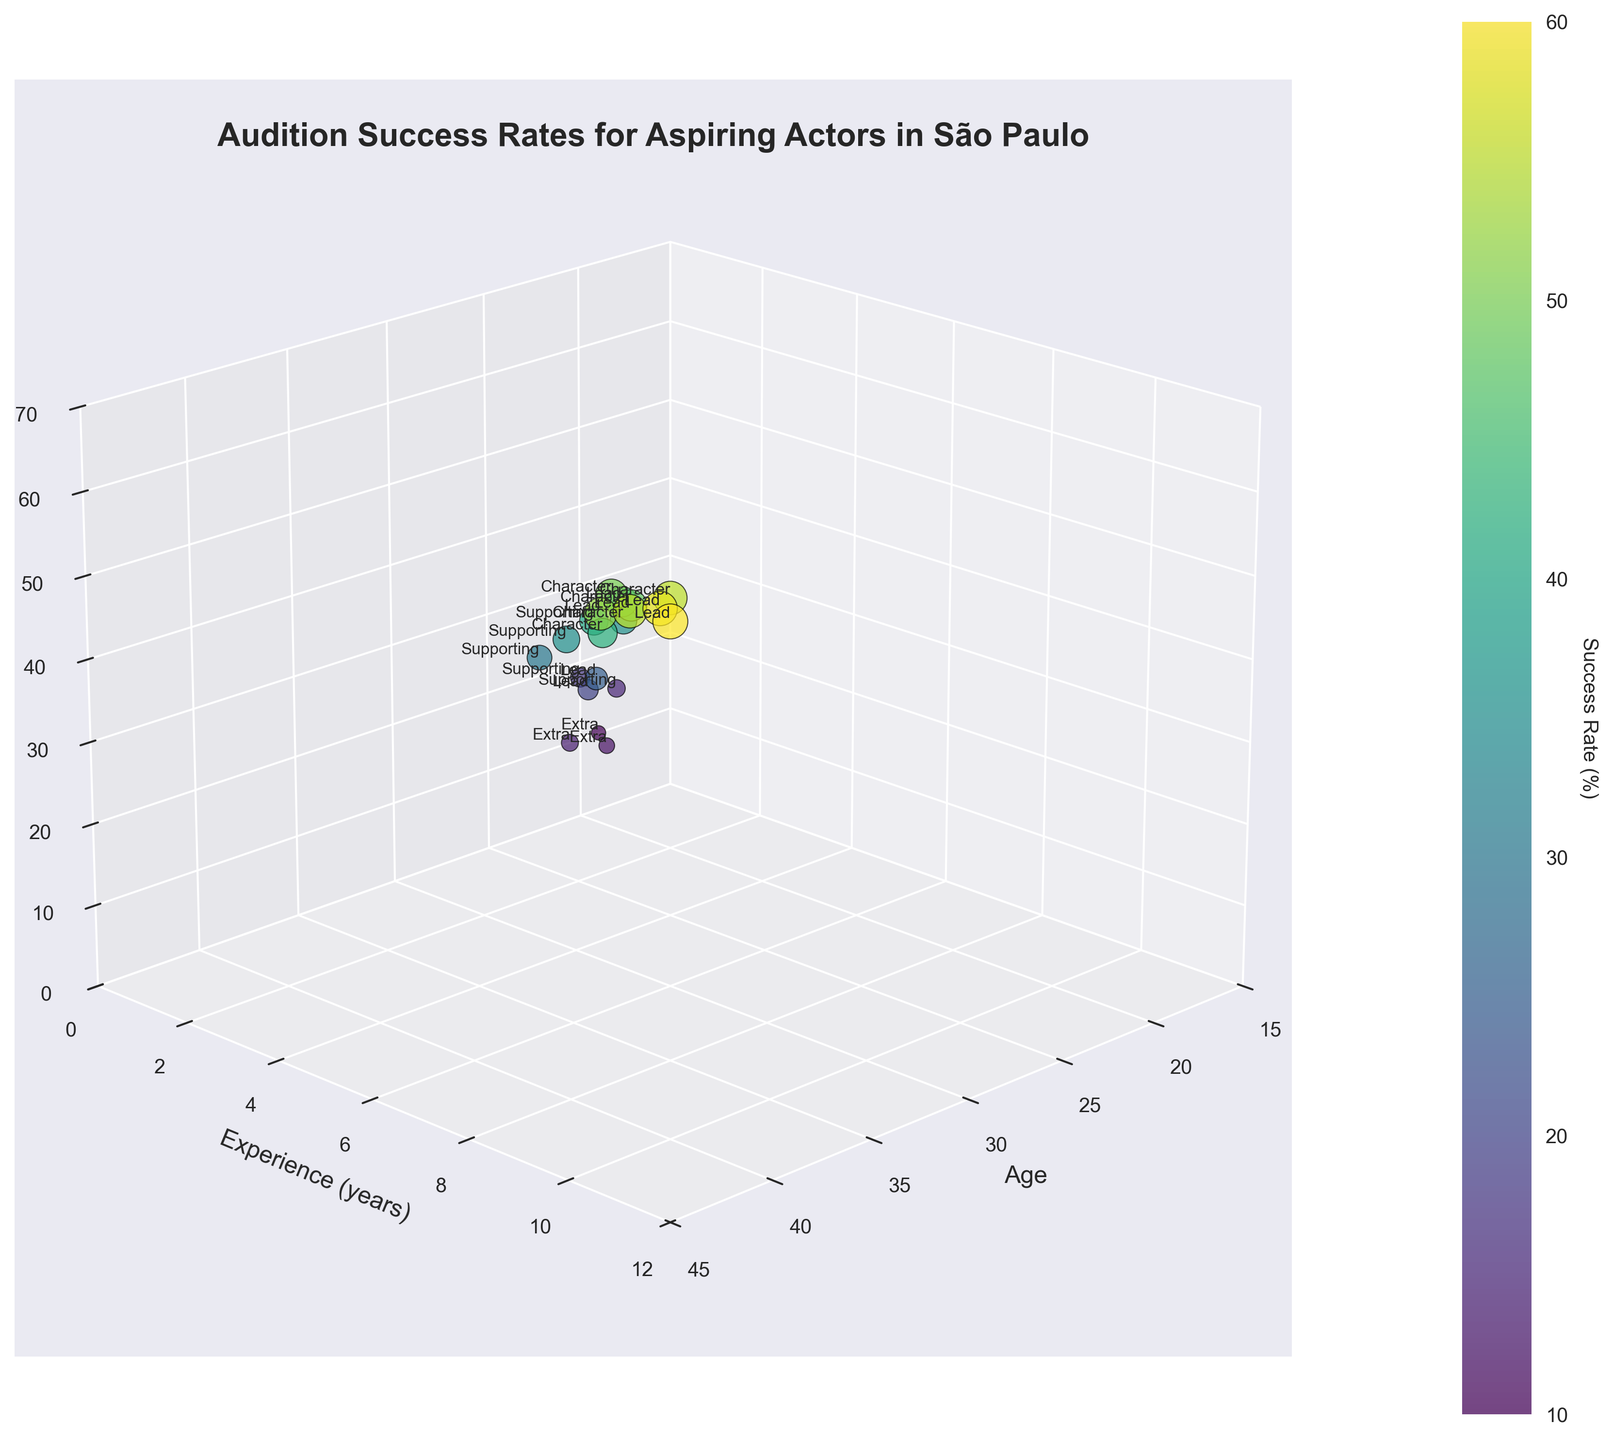What is the title of the 3D scatter plot? The title is prominently displayed at the top of the plot, which reads, "Audition Success Rates for Aspiring Actors in São Paulo".
Answer: Audition Success Rates for Aspiring Actors in São Paulo What are the labels of the X, Y, and Z axes? The labels are found next to each axis. The X-axis is labeled "Age", the Y-axis is labeled "Experience (years)", and the Z-axis is labeled "Success Rate (%)".
Answer: Age, Experience (years), Success Rate (%) Which role type has the highest success rate and what is that rate? Observe the text labels next to the points to identify the role types. The highest success rate is 60%, associated with the role type "Lead".
Answer: Lead, 60% What is the average success rate for actors with five or more years of experience? Look for data points where the experience is 5 years or more, and then calculate the average. These points have the success rates 45, 55, 50, 58, 55, and 52. The sum of these rates is (45 + 55 + 50 + 58 + 55 + 52) = 315, and there are 6 such data points. The average is 315/6 = 52.5
Answer: 52.5 How many data points are labeled with "Character"? Identify the points labeled "Character" and count them. There are 5 such points in the dataset.
Answer: 5 What is the age and experience of the actor with the highest success rate for the "Lead" role? Look at the data points labeled "Lead" and find the one with the highest success rate, which is 60%. The corresponding age and experience are 40 and 10 years respectively.
Answer: Age 40, Experience 10 years Is there a noticeable trend between age and success rate for actors in the "Supporting" role? Observe the data points labeled "Supporting". As age increases (18, 19, 20, 27, 29, 28), the success rates also seem to increase (15, 18, 30, 40, 35). The trend suggests a positive correlation between age and success rate.
Answer: Yes Which role type appears to have the most data points, and how many? Look at the plot and count the number of points for each role type. The role type "Lead" has the most data points with 6 occurrences.
Answer: Lead, 6 What is the difference in success rate between the youngest and oldest actors in the "Extra" role? Identify the youngest actor (age 19, success rate 10%) and the oldest (age 23, success rate 14%) in the "Extra" role. The difference is 14% - 10% = 4%.
Answer: 4% 